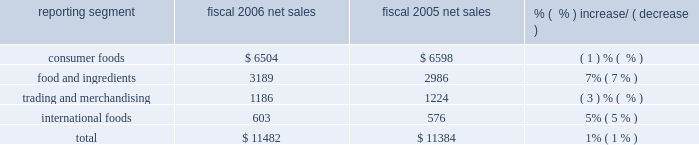Years 2002 , 2003 , 2004 , and the first two quarters of fiscal 2005 .
The restatement related to tax matters .
The company provided information to the sec staff relating to the facts and circumstances surrounding the restatement .
On july 28 , 2006 , the company filed an amendment to its annual report on form 10-k for the fiscal year ended may 29 , 2005 .
The filing amended item 6 .
Selected financial data and exhibit 12 , computation of ratios of earnings to fixed charges , for fiscal year 2001 , and certain restated financial information for fiscal years 1999 and 2000 , all related to the application of certain of the company 2019s reserves for the three years and fiscal year 1999 income tax expense .
The company provided information to the sec staff relating to the facts and circumstances surrounding the amended filing .
The company reached an agreement with the sec staff concerning matters associated with these amended filings .
That proposed settlement was approved by the securities and exchange commission on july 17 , 2007 .
On july 24 , 2007 , the sec filed its complaint against the company in the united states district court for the district of colorado , followed by an executed consent , which without the company admitting or denying the allegations of the complaint , reflects the terms of the settlement , including payment by the company of a civil penalty of $ 45 million and the company 2019s agreement to be permanently enjoined from violating certain provisions of the federal securities laws .
Additionally , the company made approximately $ 2 million in indemnity payments on behalf of former employees concluding separate settlements with the sec .
The company recorded charges of $ 25 million in fiscal 2004 , $ 21.5 million in the third quarter of fiscal 2005 , and $ 1.2 million in the first quarter of fiscal 2007 in connection with the expected settlement of these matters .
Three purported class actions were filed in united states district court for nebraska , rantala v .
Conagra foods , inc. , et .
Al. , case no .
805cv349 , and bright v .
Conagra foods , inc. , et .
Al. , case no .
805cv348 on july 18 , 2005 , and boyd v .
Conagra foods , inc. , et .
Al. , case no .
805cv386 on august 8 , 2005 .
The lawsuits are against the company , its directors and its employee benefits committee on behalf of participants in the company 2019s employee retirement income savings plans .
The lawsuits allege violations of the employee retirement income security act ( erisa ) in connection with the events resulting in the company 2019s april 2005 restatement of its financial statements and related matters .
The company has reached a settlement with the plaintiffs in these actions subject to court approval .
The settlement includes a $ 4 million payment , most of which will be paid by an insurer .
The company has also agreed to make certain prospective changes to its benefit plans as part of the settlement .
2006 vs .
2005 net sales ( $ in millions ) reporting segment fiscal 2006 net sales fiscal 2005 net sales % (  % ) increase/ ( decrease ) .
Overall , company net sales increased $ 98 million to $ 11.5 billion in fiscal 2006 , primarily reflecting favorable results in the food and ingredients and international foods segments .
Price increases driven by higher input costs for potatoes , wheat milling and dehydrated vegetables within the food and ingredients segment , coupled with the strength of foreign currencies within the international foods segment enhanced net sales .
These increases were partially offset by volume declines in the consumer foods segment , principally related to certain shelf stable brands and declines in the trading and merchandising segment related to decreased volumes and certain divestitures and closures. .
What percentage of total net sales where comprised of food and ingredients in 2006? 
Computations: (3189 / 11482)
Answer: 0.27774. 